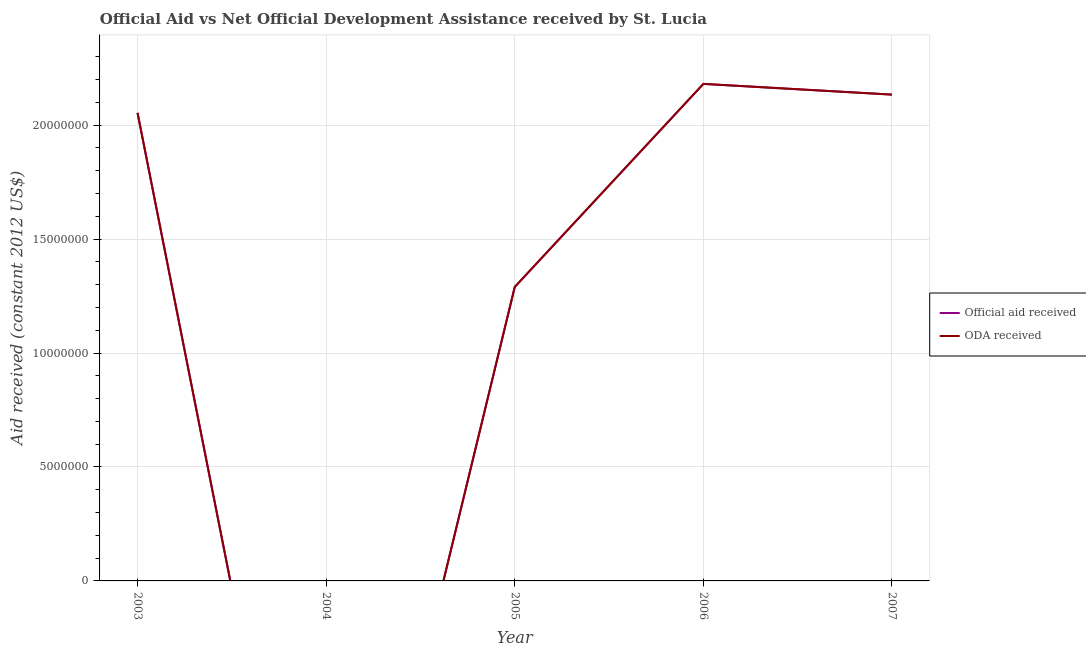How many different coloured lines are there?
Your answer should be very brief. 2. Does the line corresponding to official aid received intersect with the line corresponding to oda received?
Your answer should be very brief. Yes. What is the official aid received in 2003?
Provide a succinct answer. 2.05e+07. Across all years, what is the maximum official aid received?
Keep it short and to the point. 2.18e+07. In which year was the official aid received maximum?
Provide a short and direct response. 2006. What is the total official aid received in the graph?
Your answer should be very brief. 7.66e+07. What is the difference between the oda received in 2006 and that in 2007?
Your response must be concise. 4.70e+05. What is the difference between the oda received in 2004 and the official aid received in 2007?
Offer a terse response. -2.13e+07. What is the average oda received per year?
Your answer should be very brief. 1.53e+07. In the year 2006, what is the difference between the oda received and official aid received?
Make the answer very short. 0. What is the ratio of the official aid received in 2005 to that in 2007?
Offer a terse response. 0.6. Is the difference between the oda received in 2005 and 2006 greater than the difference between the official aid received in 2005 and 2006?
Ensure brevity in your answer.  No. What is the difference between the highest and the lowest official aid received?
Give a very brief answer. 2.18e+07. In how many years, is the official aid received greater than the average official aid received taken over all years?
Ensure brevity in your answer.  3. Is the sum of the official aid received in 2003 and 2007 greater than the maximum oda received across all years?
Keep it short and to the point. Yes. Is the official aid received strictly less than the oda received over the years?
Your response must be concise. No. How many years are there in the graph?
Give a very brief answer. 5. Are the values on the major ticks of Y-axis written in scientific E-notation?
Give a very brief answer. No. Does the graph contain grids?
Ensure brevity in your answer.  Yes. How many legend labels are there?
Offer a very short reply. 2. How are the legend labels stacked?
Offer a very short reply. Vertical. What is the title of the graph?
Your answer should be very brief. Official Aid vs Net Official Development Assistance received by St. Lucia . Does "Secondary" appear as one of the legend labels in the graph?
Provide a short and direct response. No. What is the label or title of the Y-axis?
Provide a succinct answer. Aid received (constant 2012 US$). What is the Aid received (constant 2012 US$) in Official aid received in 2003?
Offer a very short reply. 2.05e+07. What is the Aid received (constant 2012 US$) of ODA received in 2003?
Your response must be concise. 2.05e+07. What is the Aid received (constant 2012 US$) in ODA received in 2004?
Provide a short and direct response. 0. What is the Aid received (constant 2012 US$) in Official aid received in 2005?
Your answer should be very brief. 1.29e+07. What is the Aid received (constant 2012 US$) in ODA received in 2005?
Offer a terse response. 1.29e+07. What is the Aid received (constant 2012 US$) in Official aid received in 2006?
Provide a short and direct response. 2.18e+07. What is the Aid received (constant 2012 US$) of ODA received in 2006?
Offer a very short reply. 2.18e+07. What is the Aid received (constant 2012 US$) of Official aid received in 2007?
Provide a succinct answer. 2.13e+07. What is the Aid received (constant 2012 US$) in ODA received in 2007?
Your answer should be very brief. 2.13e+07. Across all years, what is the maximum Aid received (constant 2012 US$) of Official aid received?
Make the answer very short. 2.18e+07. Across all years, what is the maximum Aid received (constant 2012 US$) in ODA received?
Ensure brevity in your answer.  2.18e+07. Across all years, what is the minimum Aid received (constant 2012 US$) of Official aid received?
Make the answer very short. 0. What is the total Aid received (constant 2012 US$) of Official aid received in the graph?
Give a very brief answer. 7.66e+07. What is the total Aid received (constant 2012 US$) of ODA received in the graph?
Make the answer very short. 7.66e+07. What is the difference between the Aid received (constant 2012 US$) in Official aid received in 2003 and that in 2005?
Offer a very short reply. 7.64e+06. What is the difference between the Aid received (constant 2012 US$) in ODA received in 2003 and that in 2005?
Keep it short and to the point. 7.64e+06. What is the difference between the Aid received (constant 2012 US$) of Official aid received in 2003 and that in 2006?
Keep it short and to the point. -1.27e+06. What is the difference between the Aid received (constant 2012 US$) in ODA received in 2003 and that in 2006?
Ensure brevity in your answer.  -1.27e+06. What is the difference between the Aid received (constant 2012 US$) in Official aid received in 2003 and that in 2007?
Ensure brevity in your answer.  -8.00e+05. What is the difference between the Aid received (constant 2012 US$) in ODA received in 2003 and that in 2007?
Provide a short and direct response. -8.00e+05. What is the difference between the Aid received (constant 2012 US$) of Official aid received in 2005 and that in 2006?
Give a very brief answer. -8.91e+06. What is the difference between the Aid received (constant 2012 US$) in ODA received in 2005 and that in 2006?
Your answer should be compact. -8.91e+06. What is the difference between the Aid received (constant 2012 US$) of Official aid received in 2005 and that in 2007?
Your answer should be very brief. -8.44e+06. What is the difference between the Aid received (constant 2012 US$) of ODA received in 2005 and that in 2007?
Provide a succinct answer. -8.44e+06. What is the difference between the Aid received (constant 2012 US$) in Official aid received in 2006 and that in 2007?
Give a very brief answer. 4.70e+05. What is the difference between the Aid received (constant 2012 US$) in ODA received in 2006 and that in 2007?
Provide a succinct answer. 4.70e+05. What is the difference between the Aid received (constant 2012 US$) of Official aid received in 2003 and the Aid received (constant 2012 US$) of ODA received in 2005?
Make the answer very short. 7.64e+06. What is the difference between the Aid received (constant 2012 US$) in Official aid received in 2003 and the Aid received (constant 2012 US$) in ODA received in 2006?
Ensure brevity in your answer.  -1.27e+06. What is the difference between the Aid received (constant 2012 US$) of Official aid received in 2003 and the Aid received (constant 2012 US$) of ODA received in 2007?
Offer a terse response. -8.00e+05. What is the difference between the Aid received (constant 2012 US$) of Official aid received in 2005 and the Aid received (constant 2012 US$) of ODA received in 2006?
Your answer should be very brief. -8.91e+06. What is the difference between the Aid received (constant 2012 US$) in Official aid received in 2005 and the Aid received (constant 2012 US$) in ODA received in 2007?
Your response must be concise. -8.44e+06. What is the difference between the Aid received (constant 2012 US$) in Official aid received in 2006 and the Aid received (constant 2012 US$) in ODA received in 2007?
Give a very brief answer. 4.70e+05. What is the average Aid received (constant 2012 US$) in Official aid received per year?
Give a very brief answer. 1.53e+07. What is the average Aid received (constant 2012 US$) of ODA received per year?
Offer a terse response. 1.53e+07. In the year 2006, what is the difference between the Aid received (constant 2012 US$) of Official aid received and Aid received (constant 2012 US$) of ODA received?
Your response must be concise. 0. In the year 2007, what is the difference between the Aid received (constant 2012 US$) in Official aid received and Aid received (constant 2012 US$) in ODA received?
Provide a succinct answer. 0. What is the ratio of the Aid received (constant 2012 US$) in Official aid received in 2003 to that in 2005?
Offer a very short reply. 1.59. What is the ratio of the Aid received (constant 2012 US$) in ODA received in 2003 to that in 2005?
Offer a terse response. 1.59. What is the ratio of the Aid received (constant 2012 US$) of Official aid received in 2003 to that in 2006?
Offer a very short reply. 0.94. What is the ratio of the Aid received (constant 2012 US$) in ODA received in 2003 to that in 2006?
Ensure brevity in your answer.  0.94. What is the ratio of the Aid received (constant 2012 US$) in Official aid received in 2003 to that in 2007?
Give a very brief answer. 0.96. What is the ratio of the Aid received (constant 2012 US$) in ODA received in 2003 to that in 2007?
Provide a short and direct response. 0.96. What is the ratio of the Aid received (constant 2012 US$) of Official aid received in 2005 to that in 2006?
Ensure brevity in your answer.  0.59. What is the ratio of the Aid received (constant 2012 US$) in ODA received in 2005 to that in 2006?
Keep it short and to the point. 0.59. What is the ratio of the Aid received (constant 2012 US$) of Official aid received in 2005 to that in 2007?
Give a very brief answer. 0.6. What is the ratio of the Aid received (constant 2012 US$) of ODA received in 2005 to that in 2007?
Provide a succinct answer. 0.6. What is the ratio of the Aid received (constant 2012 US$) of Official aid received in 2006 to that in 2007?
Provide a short and direct response. 1.02. What is the ratio of the Aid received (constant 2012 US$) in ODA received in 2006 to that in 2007?
Keep it short and to the point. 1.02. What is the difference between the highest and the second highest Aid received (constant 2012 US$) in ODA received?
Offer a very short reply. 4.70e+05. What is the difference between the highest and the lowest Aid received (constant 2012 US$) of Official aid received?
Provide a succinct answer. 2.18e+07. What is the difference between the highest and the lowest Aid received (constant 2012 US$) of ODA received?
Your answer should be compact. 2.18e+07. 